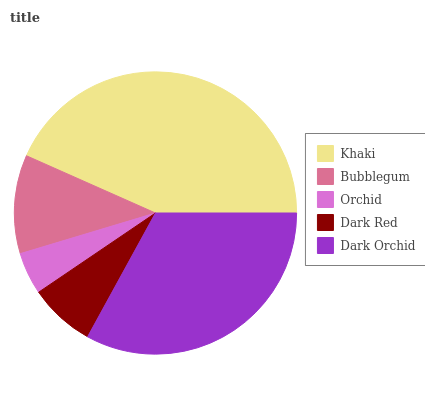Is Orchid the minimum?
Answer yes or no. Yes. Is Khaki the maximum?
Answer yes or no. Yes. Is Bubblegum the minimum?
Answer yes or no. No. Is Bubblegum the maximum?
Answer yes or no. No. Is Khaki greater than Bubblegum?
Answer yes or no. Yes. Is Bubblegum less than Khaki?
Answer yes or no. Yes. Is Bubblegum greater than Khaki?
Answer yes or no. No. Is Khaki less than Bubblegum?
Answer yes or no. No. Is Bubblegum the high median?
Answer yes or no. Yes. Is Bubblegum the low median?
Answer yes or no. Yes. Is Dark Orchid the high median?
Answer yes or no. No. Is Orchid the low median?
Answer yes or no. No. 